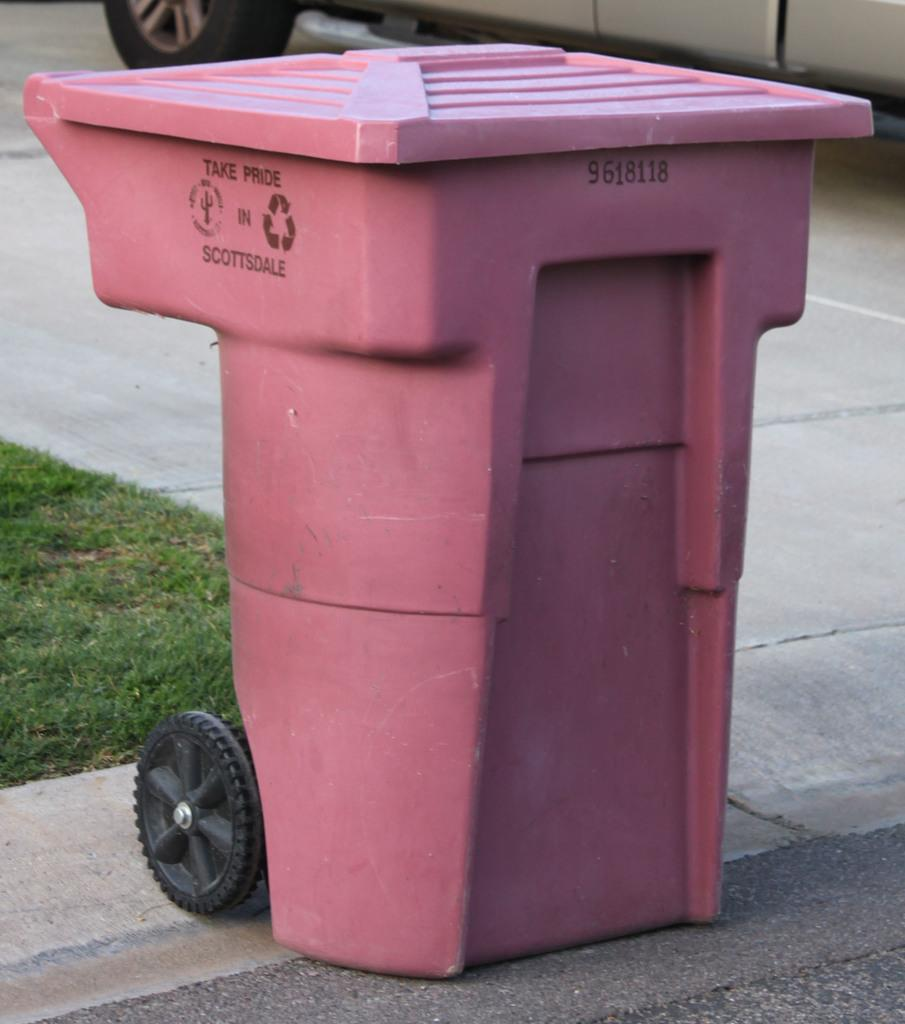<image>
Present a compact description of the photo's key features. A pink trash can in Scottsdale sits on the curb. 